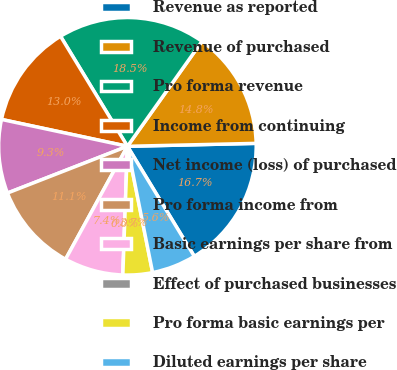Convert chart. <chart><loc_0><loc_0><loc_500><loc_500><pie_chart><fcel>Revenue as reported<fcel>Revenue of purchased<fcel>Pro forma revenue<fcel>Income from continuing<fcel>Net income (loss) of purchased<fcel>Pro forma income from<fcel>Basic earnings per share from<fcel>Effect of purchased businesses<fcel>Pro forma basic earnings per<fcel>Diluted earnings per share<nl><fcel>16.67%<fcel>14.81%<fcel>18.52%<fcel>12.96%<fcel>9.26%<fcel>11.11%<fcel>7.41%<fcel>0.0%<fcel>3.7%<fcel>5.56%<nl></chart> 